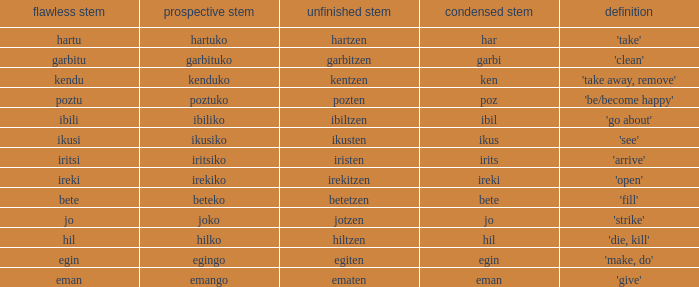What is the number for future stem for poztu? 1.0. 